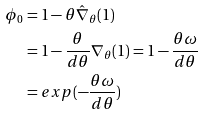<formula> <loc_0><loc_0><loc_500><loc_500>\phi _ { 0 } & = 1 - \theta \hat { \nabla } _ { \theta } ( 1 ) \\ & = 1 - \frac { \theta } { d \theta } \nabla _ { \theta } ( 1 ) = 1 - \frac { \theta \omega } { d \theta } \\ & = e x p ( - \frac { \theta \omega } { d \theta } )</formula> 